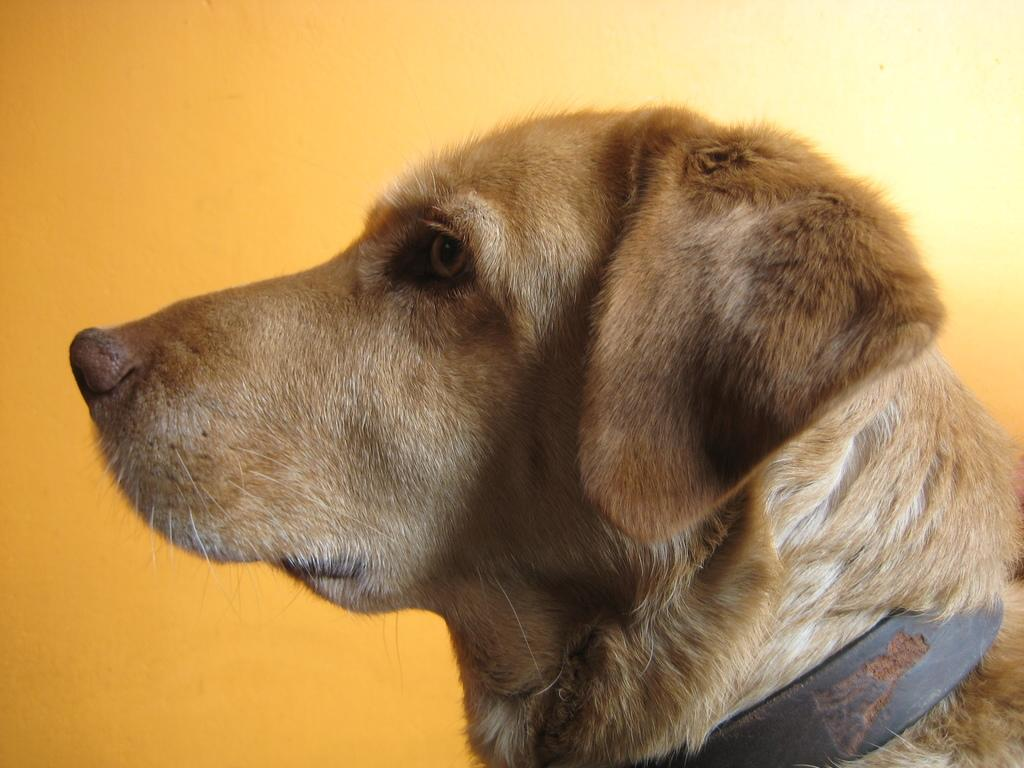What type of animal is present in the image? There is a dog in the image. What color is the wall visible in the background of the image? There is a yellow wall in the background of the image. How much money does the dog have in the image? There is no indication of money or any financial transactions involving the dog in the image. 